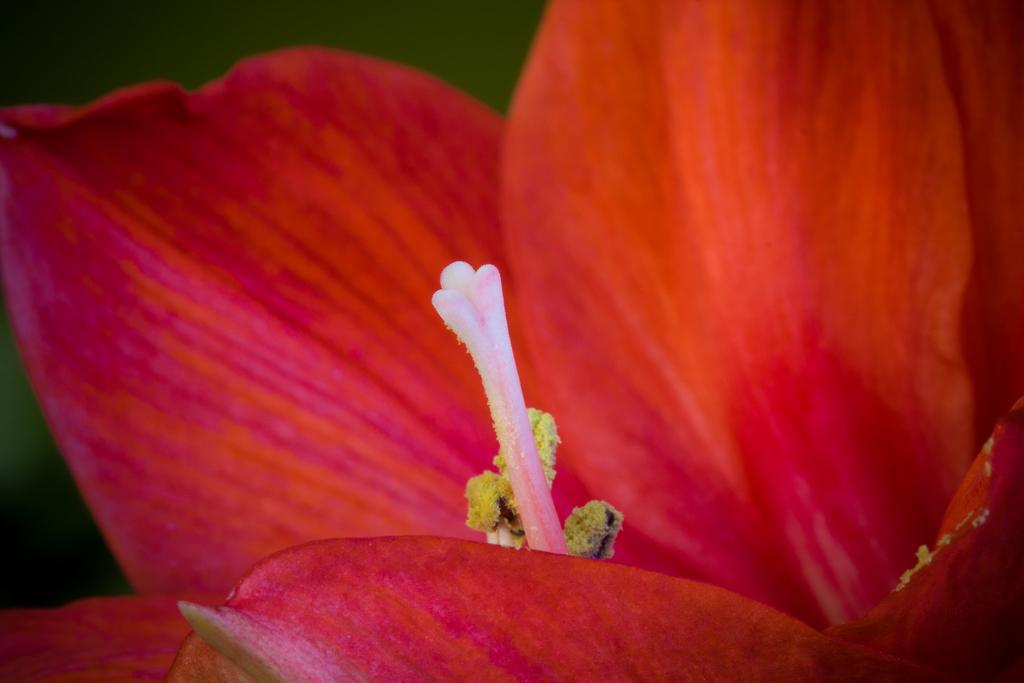How would you summarize this image in a sentence or two? In this image we can see flower. 